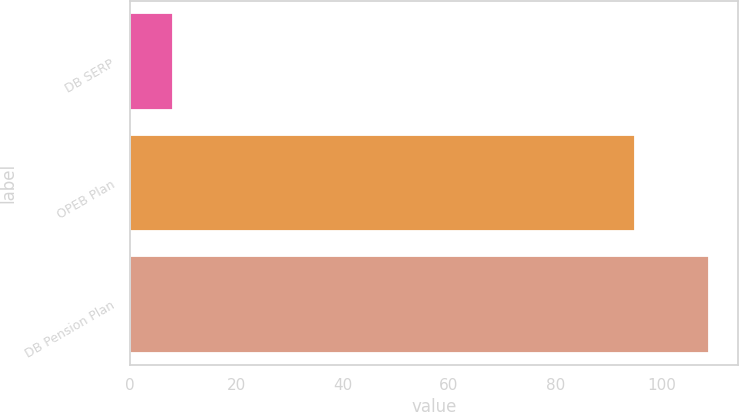Convert chart. <chart><loc_0><loc_0><loc_500><loc_500><bar_chart><fcel>DB SERP<fcel>OPEB Plan<fcel>DB Pension Plan<nl><fcel>8<fcel>95<fcel>109<nl></chart> 